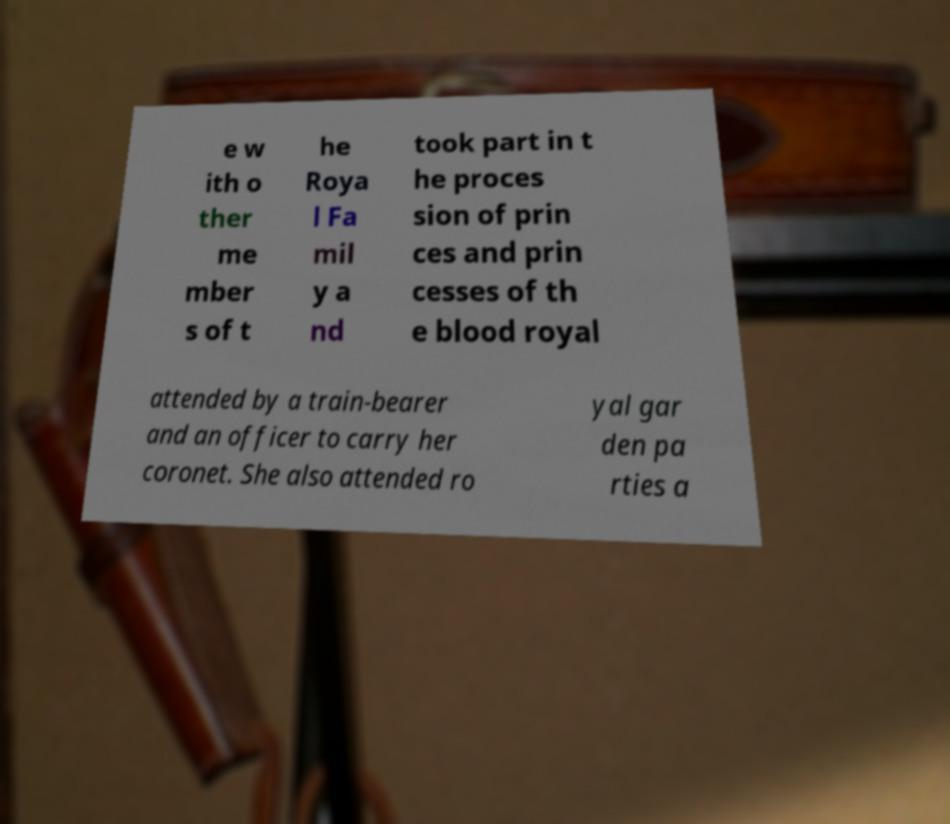I need the written content from this picture converted into text. Can you do that? e w ith o ther me mber s of t he Roya l Fa mil y a nd took part in t he proces sion of prin ces and prin cesses of th e blood royal attended by a train-bearer and an officer to carry her coronet. She also attended ro yal gar den pa rties a 